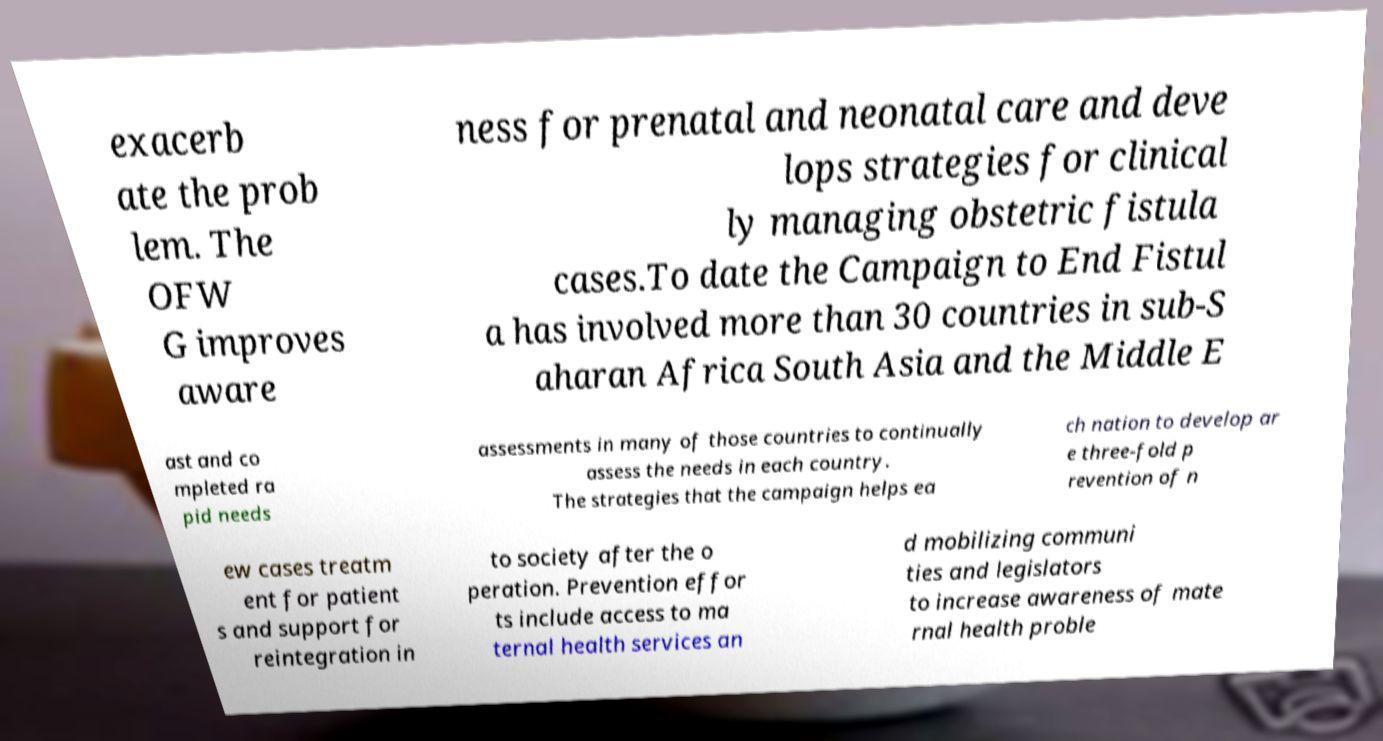Please identify and transcribe the text found in this image. exacerb ate the prob lem. The OFW G improves aware ness for prenatal and neonatal care and deve lops strategies for clinical ly managing obstetric fistula cases.To date the Campaign to End Fistul a has involved more than 30 countries in sub-S aharan Africa South Asia and the Middle E ast and co mpleted ra pid needs assessments in many of those countries to continually assess the needs in each country. The strategies that the campaign helps ea ch nation to develop ar e three-fold p revention of n ew cases treatm ent for patient s and support for reintegration in to society after the o peration. Prevention effor ts include access to ma ternal health services an d mobilizing communi ties and legislators to increase awareness of mate rnal health proble 